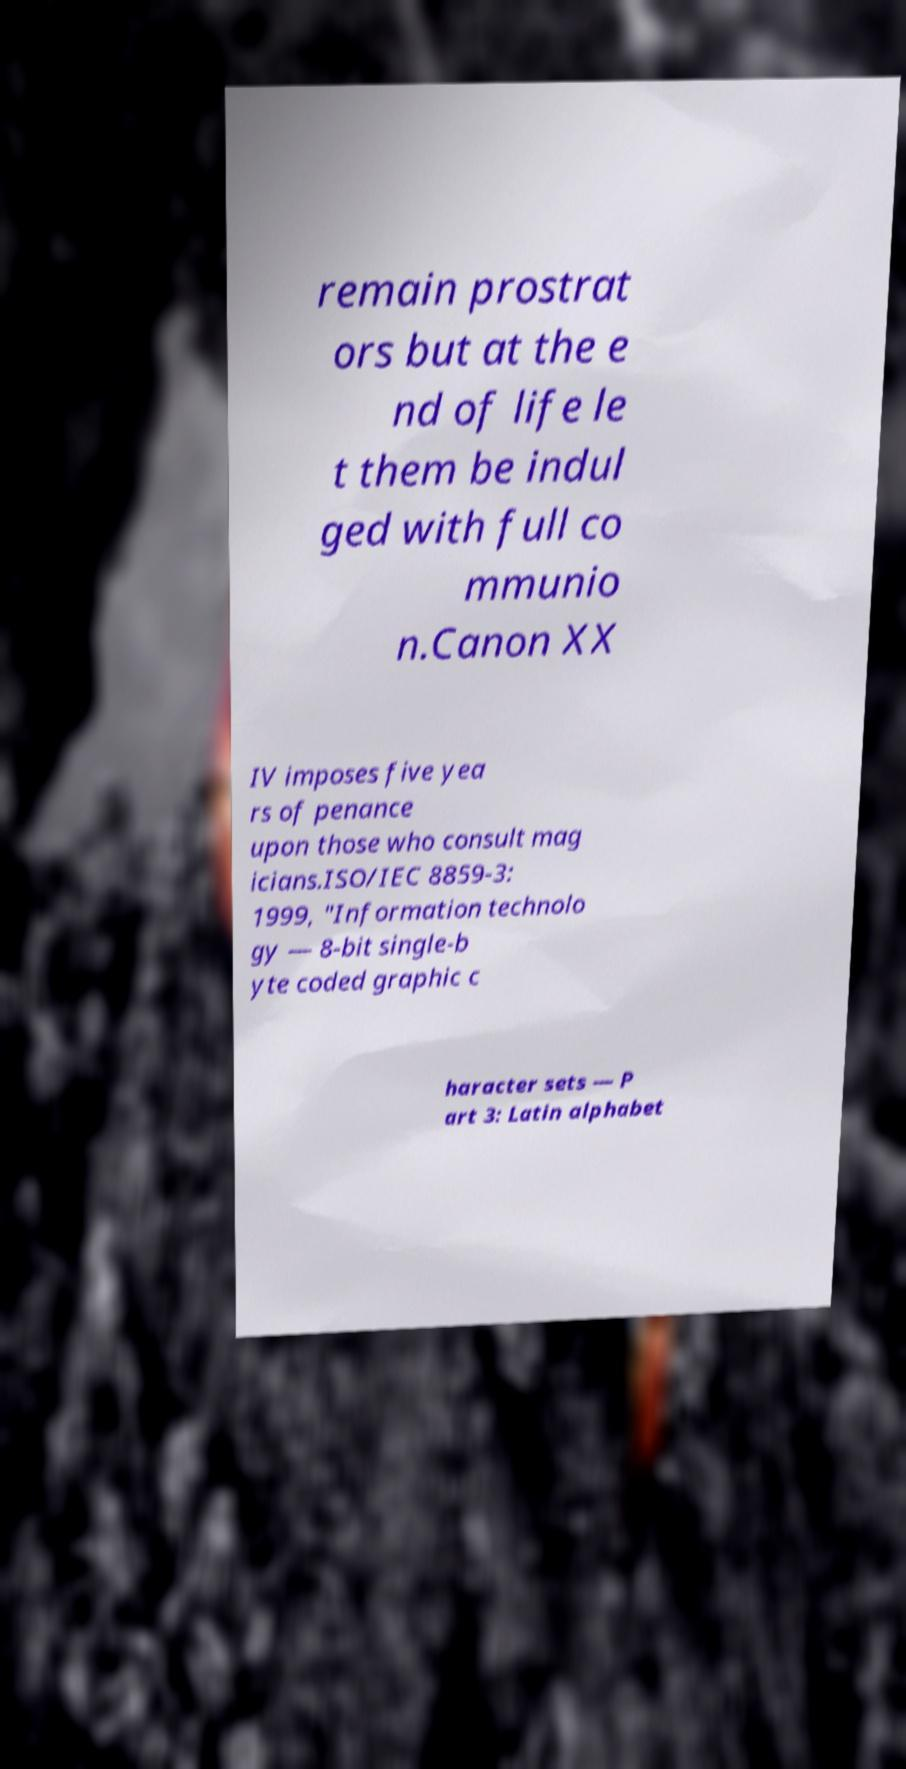For documentation purposes, I need the text within this image transcribed. Could you provide that? remain prostrat ors but at the e nd of life le t them be indul ged with full co mmunio n.Canon XX IV imposes five yea rs of penance upon those who consult mag icians.ISO/IEC 8859-3: 1999, "Information technolo gy — 8-bit single-b yte coded graphic c haracter sets — P art 3: Latin alphabet 